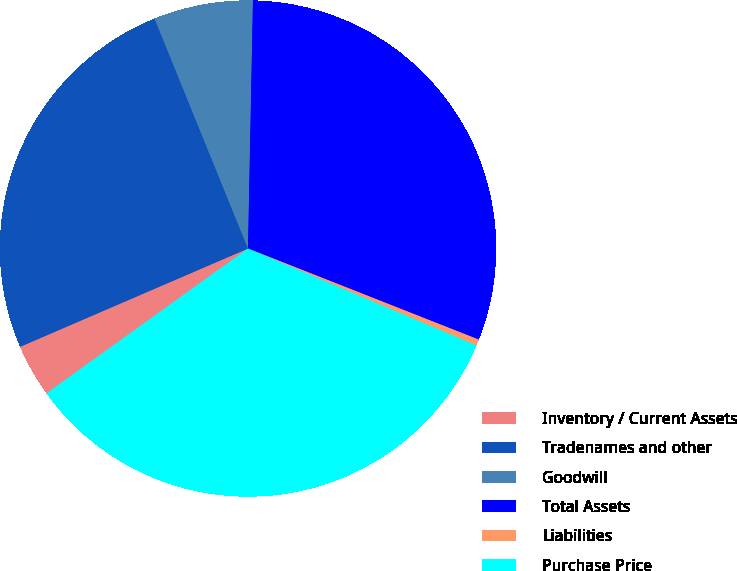Convert chart. <chart><loc_0><loc_0><loc_500><loc_500><pie_chart><fcel>Inventory / Current Assets<fcel>Tradenames and other<fcel>Goodwill<fcel>Total Assets<fcel>Liabilities<fcel>Purchase Price<nl><fcel>3.44%<fcel>25.34%<fcel>6.46%<fcel>30.67%<fcel>0.41%<fcel>33.69%<nl></chart> 